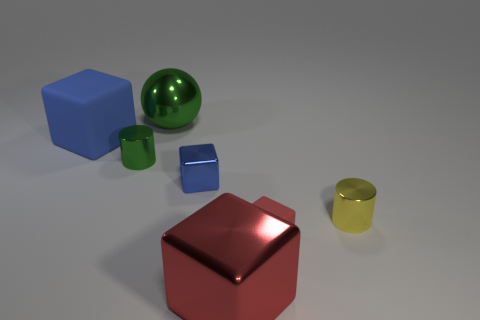What is the shape of the red metal thing that is to the left of the tiny object that is right of the tiny red rubber thing?
Offer a very short reply. Cube. Is the number of tiny things less than the number of tiny cyan things?
Offer a very short reply. No. Is the material of the tiny yellow thing the same as the big green object?
Offer a very short reply. Yes. What color is the big thing that is in front of the green sphere and behind the large red metallic thing?
Offer a terse response. Blue. Is there a rubber cylinder of the same size as the yellow metallic thing?
Give a very brief answer. No. What size is the cylinder right of the small object behind the small metal block?
Offer a very short reply. Small. Are there fewer green metal cylinders behind the large green object than big purple rubber spheres?
Ensure brevity in your answer.  No. Is the color of the big sphere the same as the tiny metal block?
Give a very brief answer. No. How big is the yellow cylinder?
Provide a short and direct response. Small. How many rubber things are the same color as the big metal cube?
Keep it short and to the point. 1. 